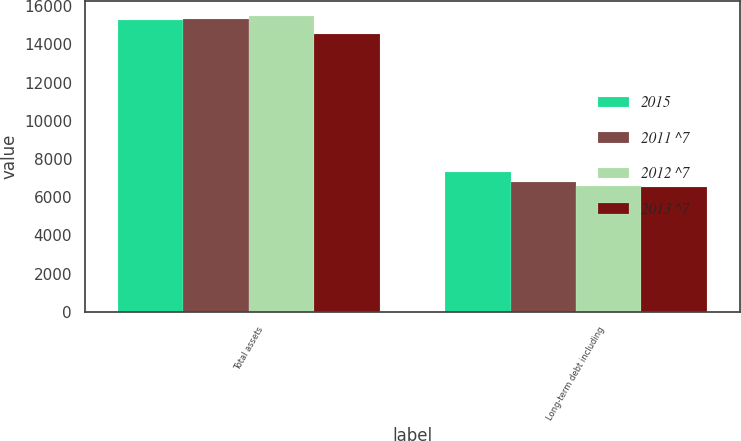Convert chart to OTSL. <chart><loc_0><loc_0><loc_500><loc_500><stacked_bar_chart><ecel><fcel>Total assets<fcel>Long-term debt including<nl><fcel>2015<fcel>15303<fcel>7338<nl><fcel>2011 ^7<fcel>15326<fcel>6812<nl><fcel>2012 ^7<fcel>15480<fcel>6590<nl><fcel>2013 ^7<fcel>14525<fcel>6519<nl></chart> 